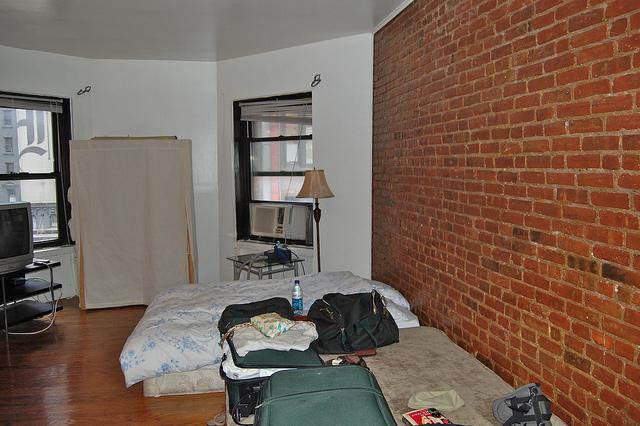What is in the window?
Give a very brief answer. Air conditioner. Does the suitcase have a zipper?
Short answer required. Yes. Is the person who lives in this room most likely rich or poor?
Quick response, please. Poor. What is in the suitcase?
Quick response, please. Clothes. How many lamps are in the room?
Concise answer only. 1. 